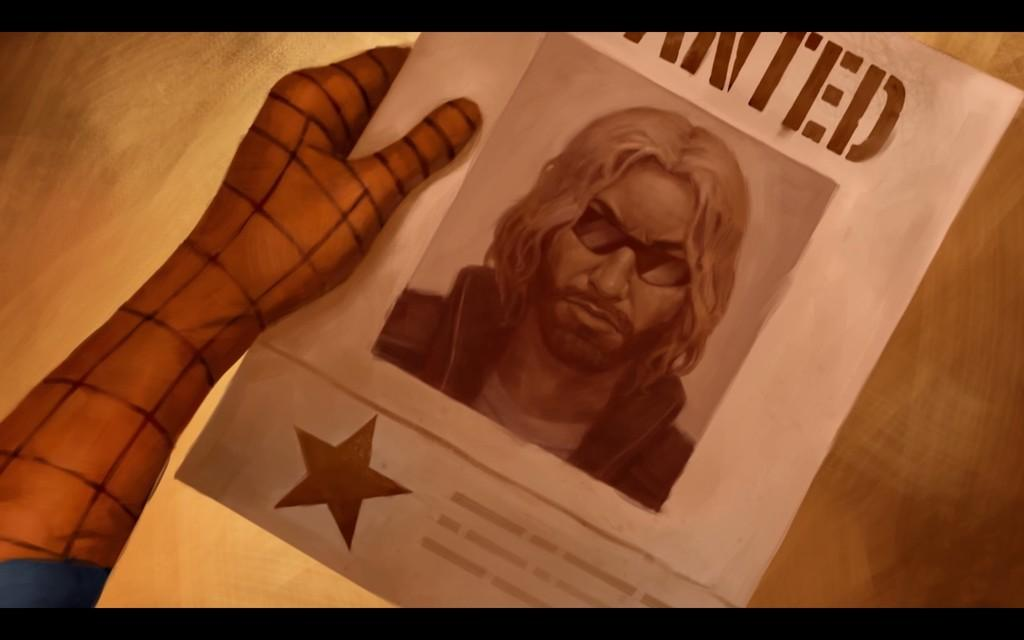<image>
Relay a brief, clear account of the picture shown. a wanted paper with a man that has sunglasses 